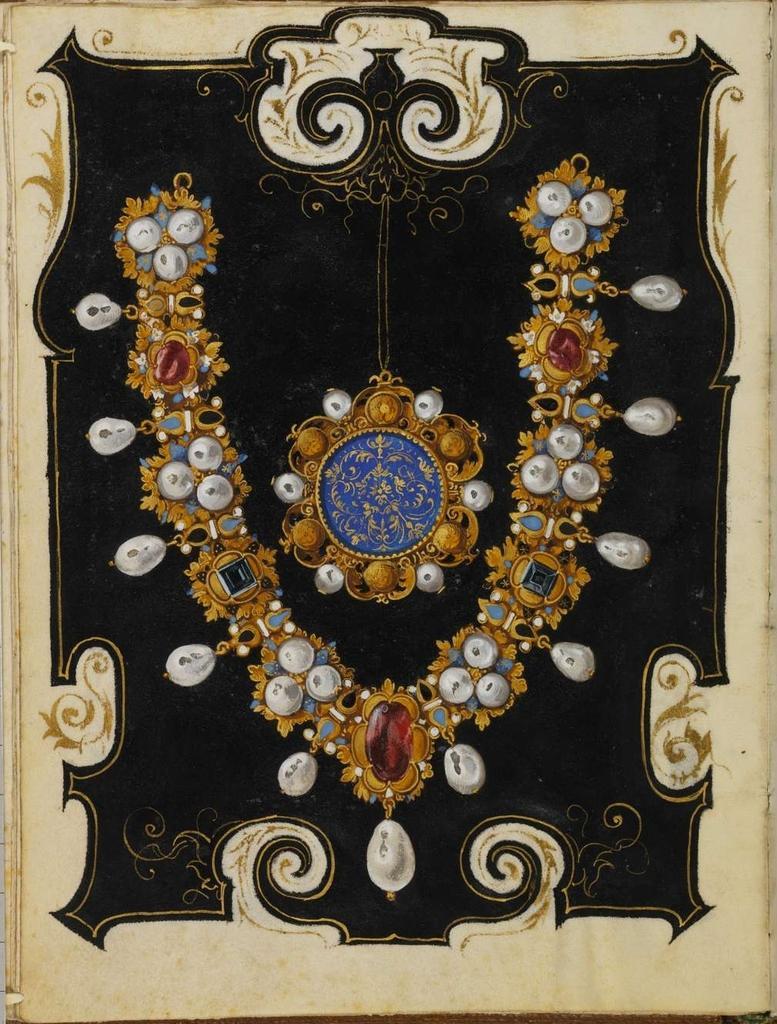How would you summarize this image in a sentence or two? This is a painting. In this image there is a painting of an ornaments and there are jewels in white, in red and in green colors. 